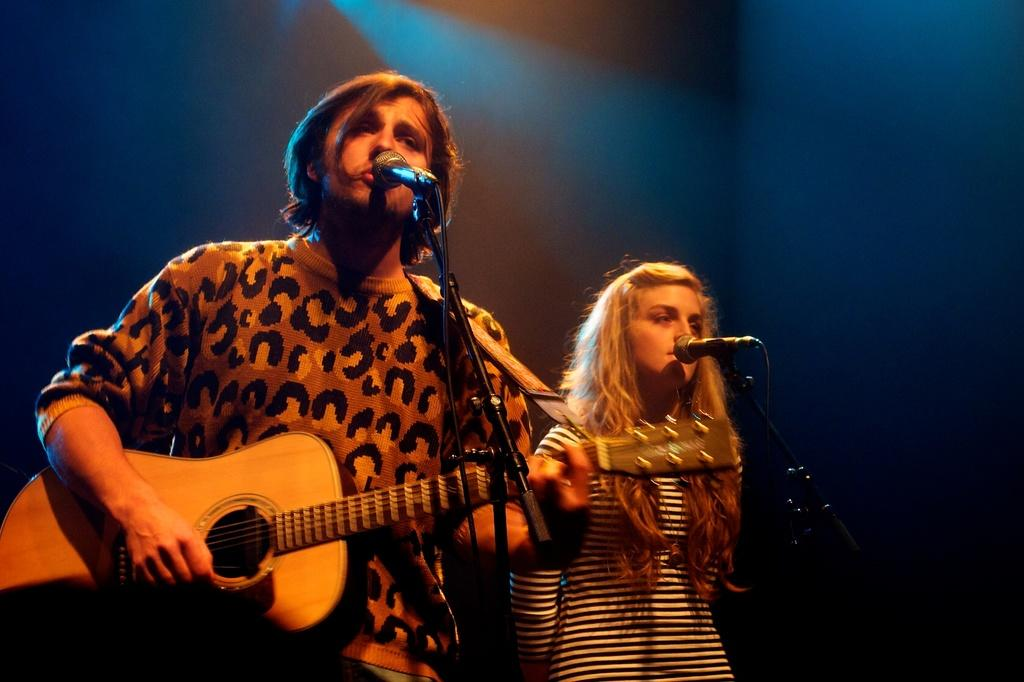What is the man in the picture doing? The man is playing a guitar. What is the woman in the picture doing? The woman is singing and holding a microphone. What object can be seen in the picture that is used for supporting the guitar? There is a stand in the picture. What is visible in the background of the picture? There is a wall in the background of the picture. What type of shoes is the man wearing in the picture? There is no information about the man's shoes in the image, so we cannot determine what type of shoes he is wearing. Is there a box visible in the picture? No, there is no box present in the image. 